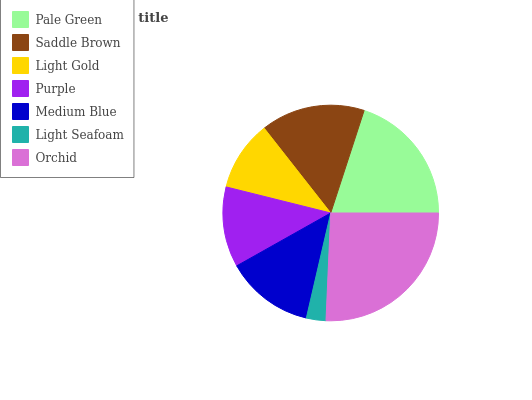Is Light Seafoam the minimum?
Answer yes or no. Yes. Is Orchid the maximum?
Answer yes or no. Yes. Is Saddle Brown the minimum?
Answer yes or no. No. Is Saddle Brown the maximum?
Answer yes or no. No. Is Pale Green greater than Saddle Brown?
Answer yes or no. Yes. Is Saddle Brown less than Pale Green?
Answer yes or no. Yes. Is Saddle Brown greater than Pale Green?
Answer yes or no. No. Is Pale Green less than Saddle Brown?
Answer yes or no. No. Is Medium Blue the high median?
Answer yes or no. Yes. Is Medium Blue the low median?
Answer yes or no. Yes. Is Light Gold the high median?
Answer yes or no. No. Is Light Gold the low median?
Answer yes or no. No. 